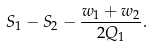<formula> <loc_0><loc_0><loc_500><loc_500>S _ { 1 } - S _ { 2 } - \frac { w _ { 1 } + w _ { 2 } } { 2 Q _ { 1 } } .</formula> 